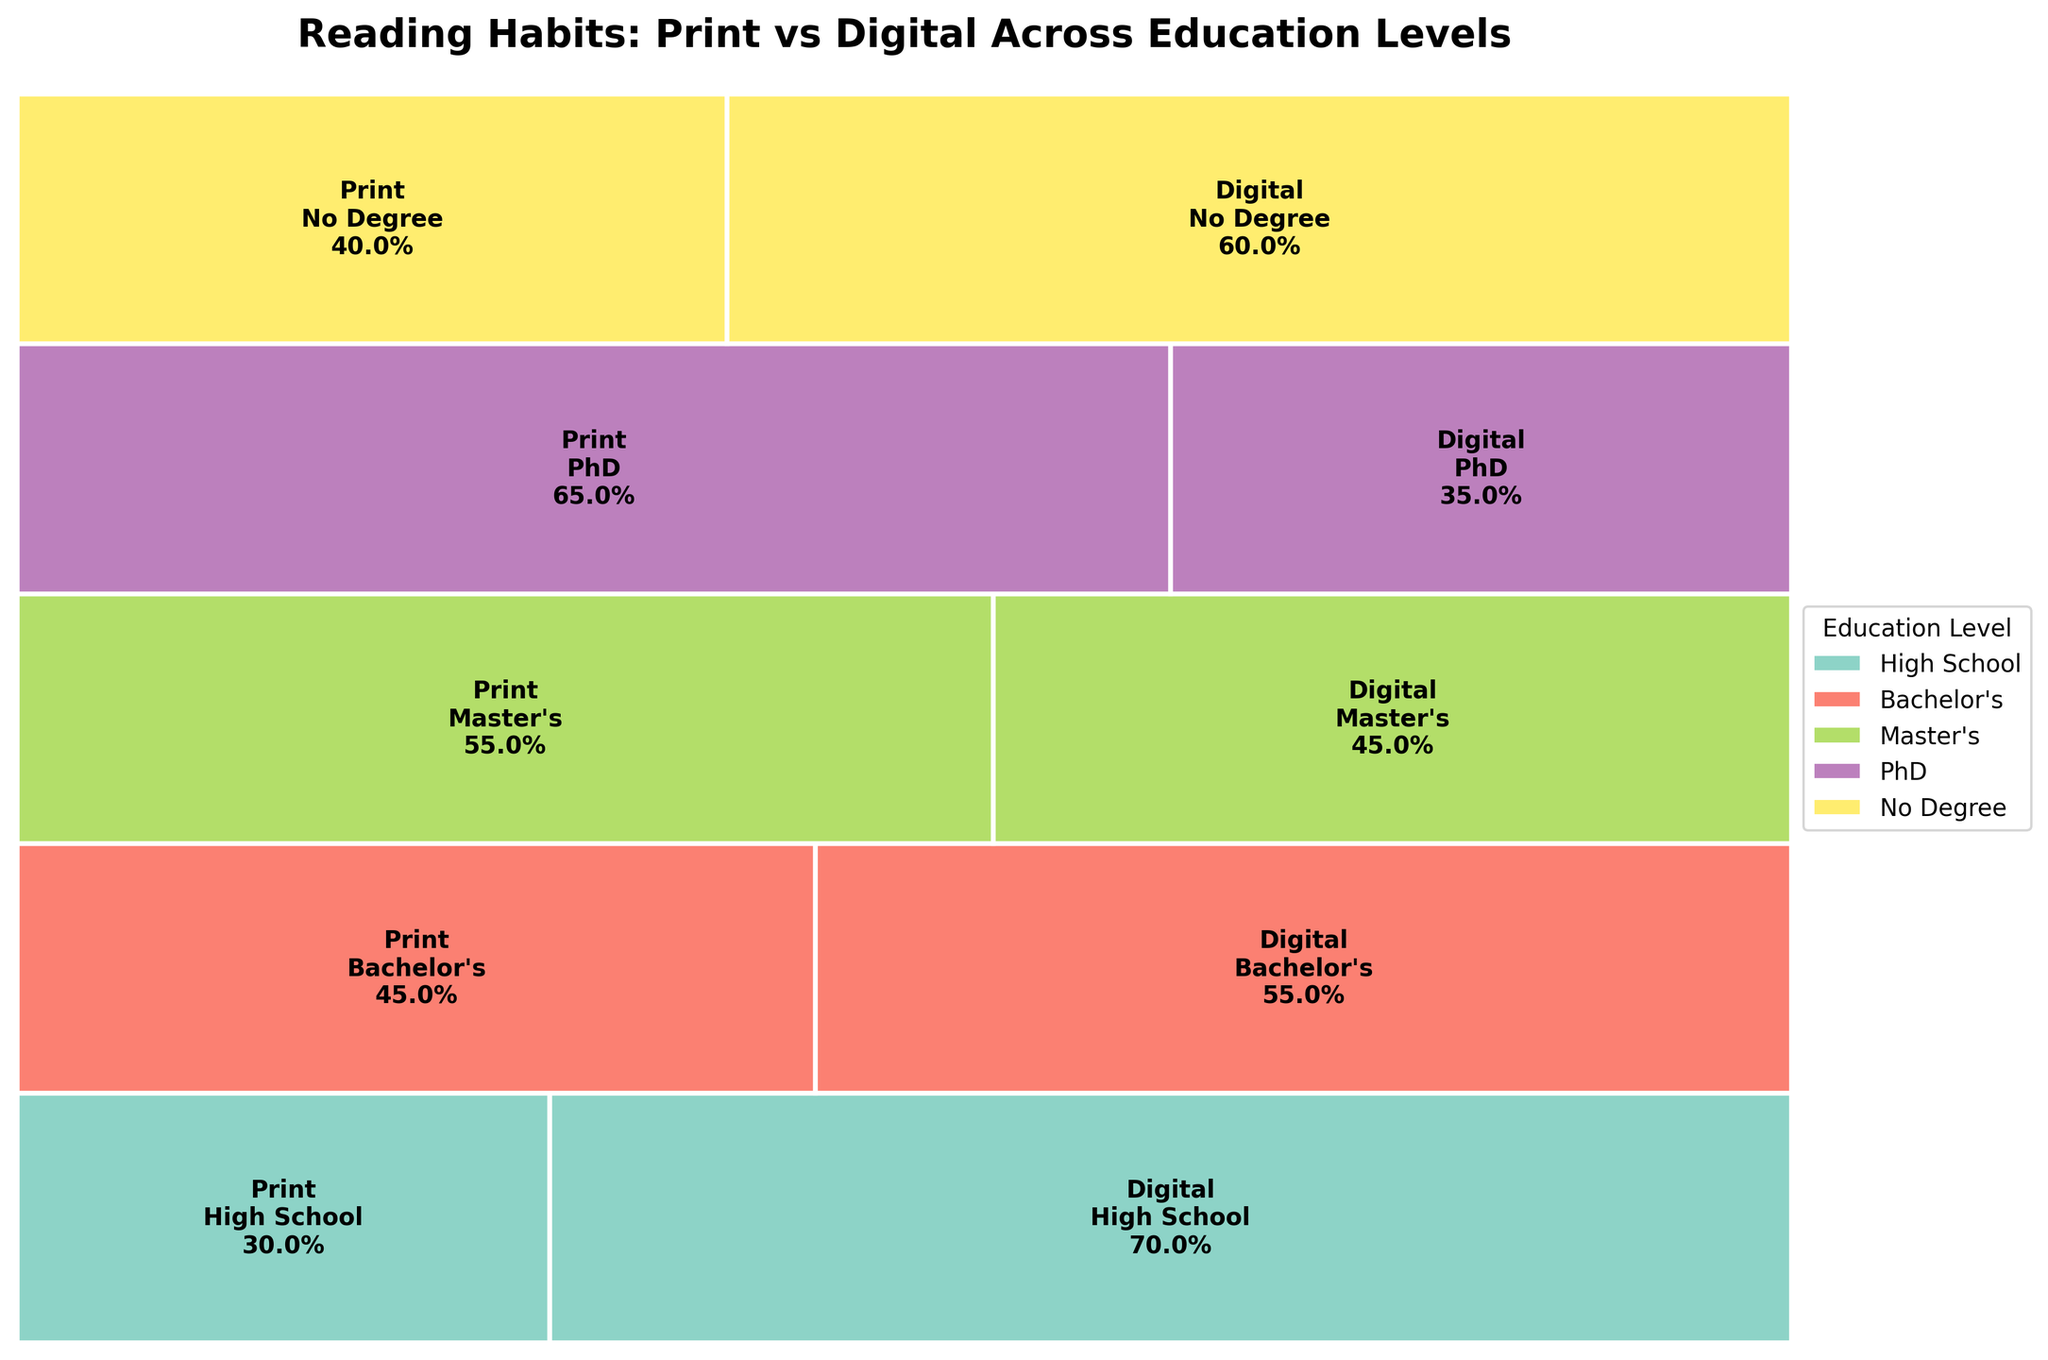What is the title of the plot? The title of the plot is displayed at the top of the figure. It provides the main subject of the visualized data. By looking at the figure, the title "Reading Habits: Print vs Digital Across Education Levels" is clearly visible.
Answer: Reading Habits: Print vs Digital Across Education Levels Which format is more preferred by High School graduates? To answer this question, look at the rectangles representing High School graduates. The larger rectangle between Print and Digital indicates the more preferred format. The wider section under Digital format shows a larger proportion of High School graduates prefer Digital.
Answer: Digital Which education level has the highest preference for Print books? By comparing the sizes of the Print rectangles across different education levels, the rectangle with the largest area will indicate the highest preference. The PhD level has the largest rectangle for Print books.
Answer: PhD What percentage of Master's graduates prefer Digital over Print? Look at the section corresponding to Master's graduates and Digital format. The percentage is labeled inside the rectangles. The label inside the Digital section for Master's shows 45%.
Answer: 45% Is the preference for Digital format higher or lower for Bachelor's compared to No Degree holders? Check the sizes and percentages within the rectangles for both Bachelor's and No Degree holders under the Digital format. Bachelor's holders have 55%, while No Degree holders have 60%, indicating that No Degree holders prefer Digital more.
Answer: Lower Which education level shows the least disparity between preferences for Print and Digital formats? Examine the differences in the rectangle sizes for each education level. The closer the sizes are to each other, the less disparity there is. The Master's level shows similar-sized rectangles for Print (55%) and Digital (45%), indicating the least disparity.
Answer: Master's What is the total height proportion of PhD and No Degree combined compared to the total height? Calculate the total preference for each education level and sum those for PhD and No Degree. Add the relative heights (since they sum to 100%). Both PhD and No Degree have equal areas representing 100%, thereby covering the figure fully.
Answer: 100% Which format is uniformly preferred across all education levels? To answer this, observe if any format consistently holds a larger or balanced proportion across varied education levels. Observing the plot, it's noticeable that preferences vary and no single format is uniformly preferred.
Answer: None What are the preferences among Master's and PhD holders for Print books in terms of relative proportion? Compare the percentage labels within the Print sections for Master's and PhD. Master's have 55% preference for Print, while PhD holders have a 65% preference for Print format.
Answer: 55% for Master's, 65% for PhD If total preferences summed up to 500, how many people from Bachelor's category prefer Print books? Given the plot proportion where Bachelor’s preference for Print is 45%. Calculate 45% of the overall Bachelor’s sum from the plot. The total number of preferences for Print within Bachelor's is calculated by adding the provided data’s specifics.
Answer: 45 